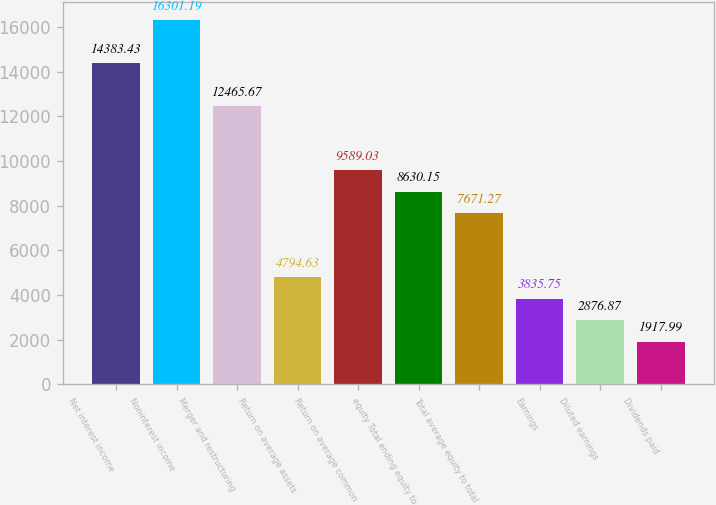Convert chart. <chart><loc_0><loc_0><loc_500><loc_500><bar_chart><fcel>Net interest income<fcel>Noninterest income<fcel>Merger and restructuring<fcel>Return on average assets<fcel>Return on average common<fcel>equity Total ending equity to<fcel>Total average equity to total<fcel>Earnings<fcel>Diluted earnings<fcel>Dividends paid<nl><fcel>14383.4<fcel>16301.2<fcel>12465.7<fcel>4794.63<fcel>9589.03<fcel>8630.15<fcel>7671.27<fcel>3835.75<fcel>2876.87<fcel>1917.99<nl></chart> 